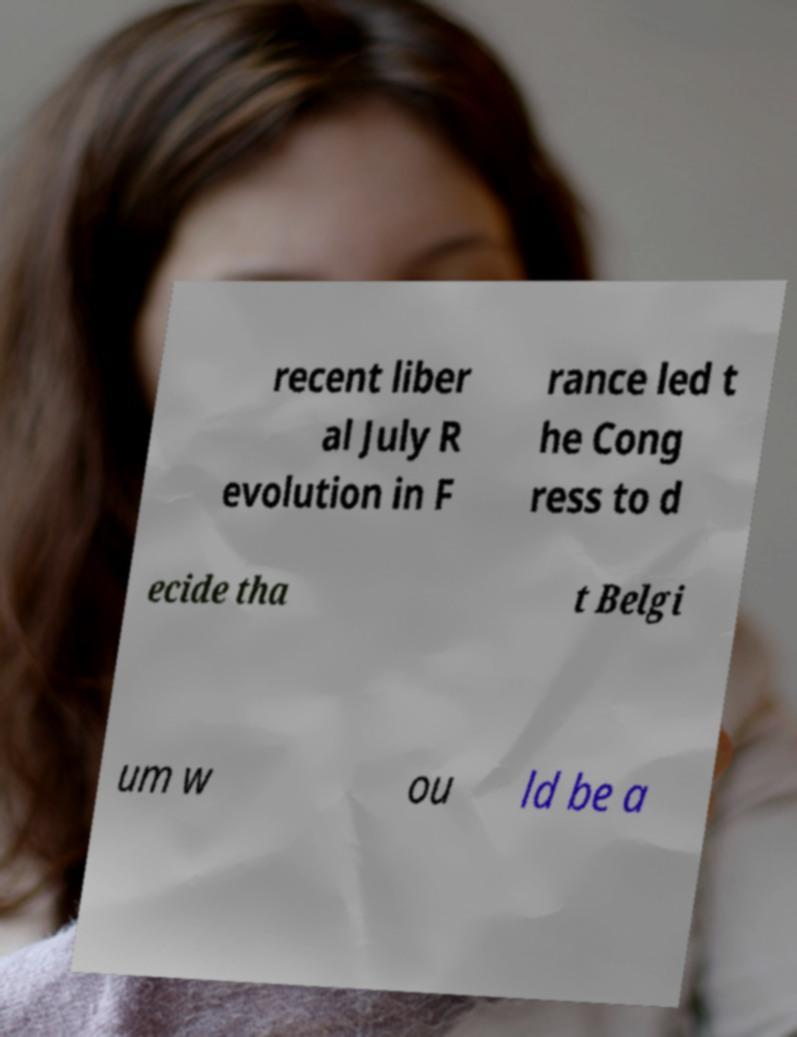For documentation purposes, I need the text within this image transcribed. Could you provide that? recent liber al July R evolution in F rance led t he Cong ress to d ecide tha t Belgi um w ou ld be a 